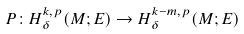<formula> <loc_0><loc_0><loc_500><loc_500>P \colon H ^ { k , p } _ { \delta } ( M ; E ) \to H ^ { k - m , p } _ { \delta } ( M ; E )</formula> 